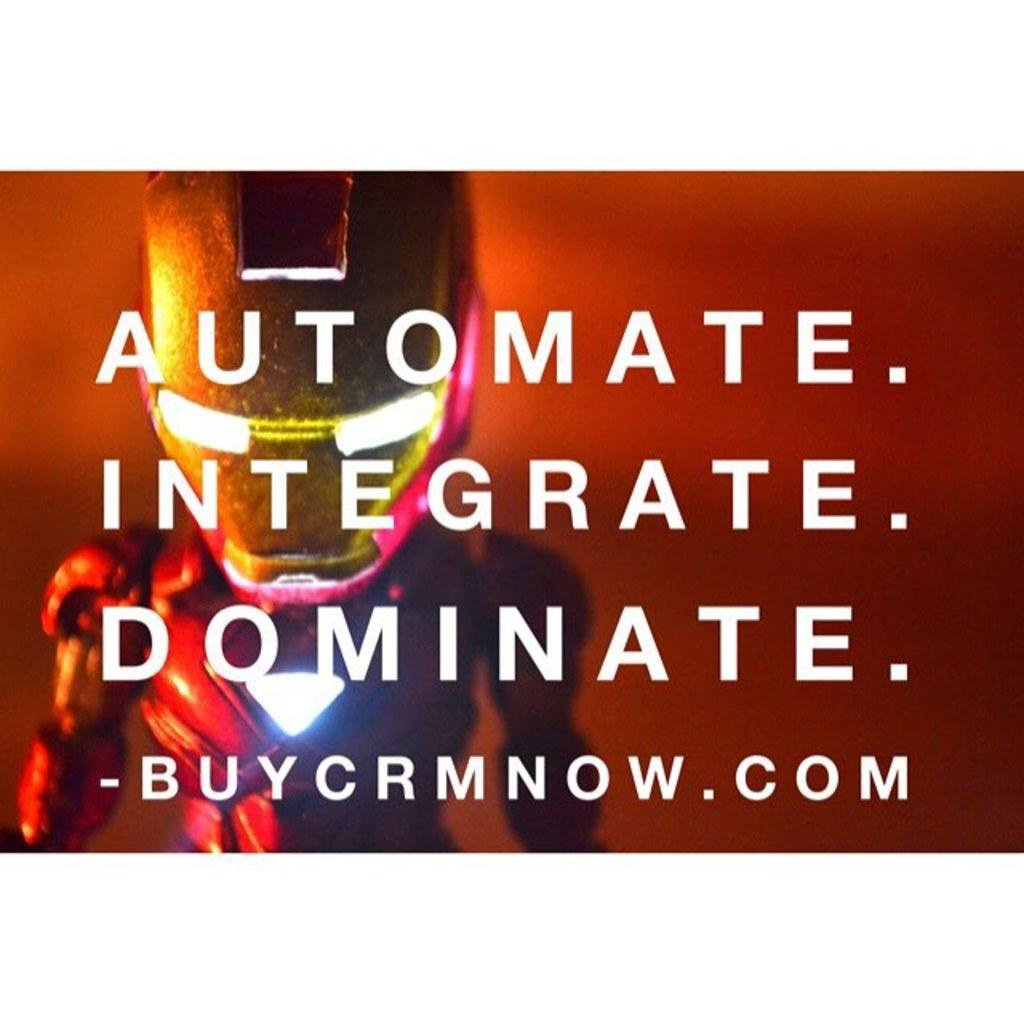<image>
Relay a brief, clear account of the picture shown. iron man standing behind "automate. integrate. dominate. -buycrmnow.com" 